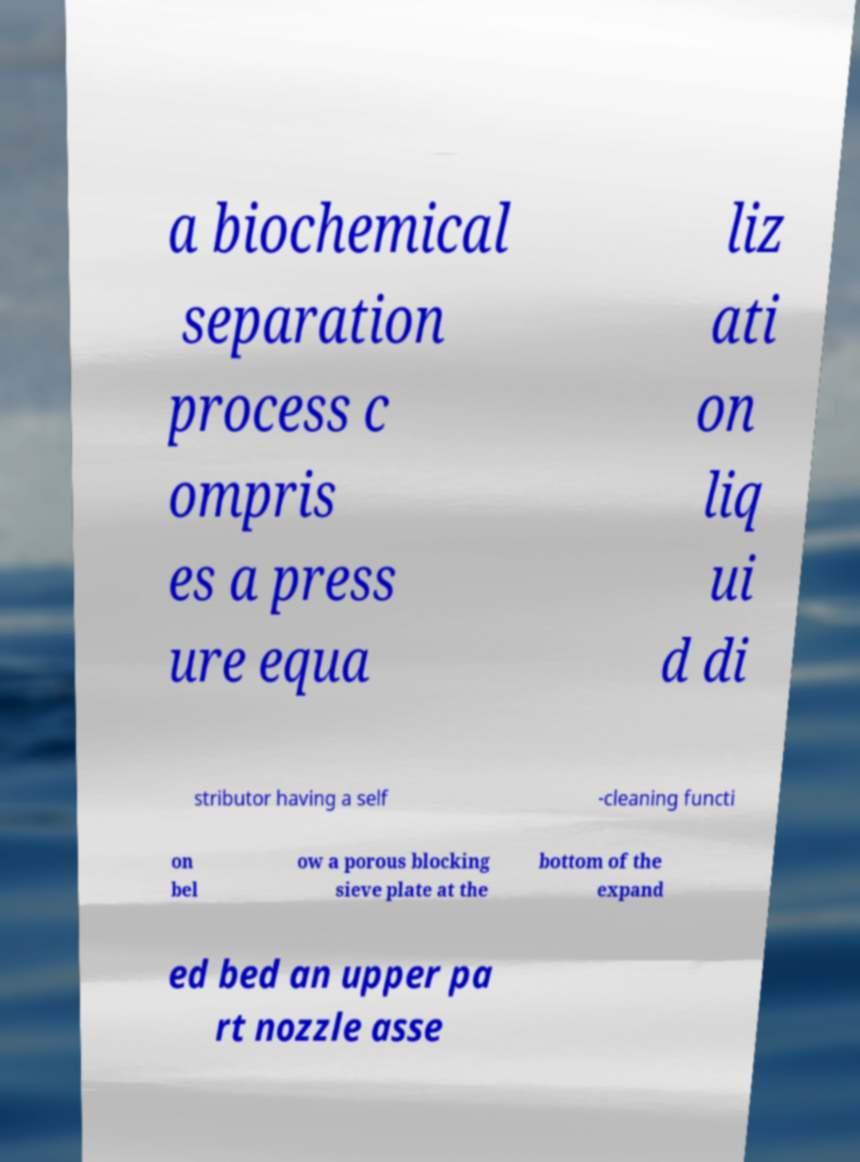I need the written content from this picture converted into text. Can you do that? a biochemical separation process c ompris es a press ure equa liz ati on liq ui d di stributor having a self -cleaning functi on bel ow a porous blocking sieve plate at the bottom of the expand ed bed an upper pa rt nozzle asse 